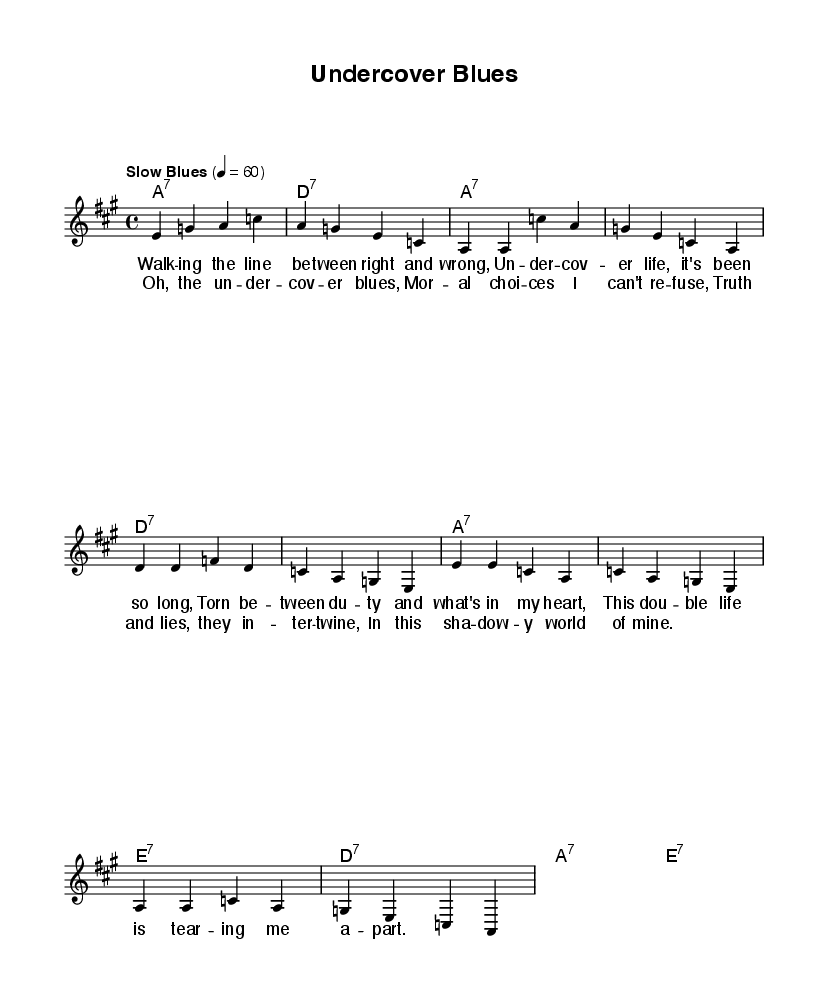What is the key signature of this music? The key signature is indicated by the presence of sharps or flats at the beginning of the staff. This piece is in A major, which has three sharps: F#, C#, and G#.
Answer: A major What is the time signature of this music? The time signature is shown at the beginning of the piece. It is written as 4/4, meaning there are four beats in each measure and the quarter note receives one beat.
Answer: 4/4 What is the tempo of this music? The tempo marking is placed above the staff and indicates the speed of the music. In this case, it states "Slow Blues" with a metronome marking of 60 beats per minute, indicating a slow tempo typical of blues music.
Answer: Slow Blues What is the main theme of the lyrics in the verses? By interpreting the lyrics provided, the themes revolve around moral dilemmas and the conflict between duty and personal feelings as an undercover agent. This reflects the struggles faced in a double life.
Answer: Moral dilemmas How many measures are in the chorus? The chorus consists of four lines with each line containing one measure. Therefore, there are a total of four measures in the chorus section.
Answer: Four measures What genre can this piece be classified as? The elements present in the music—like the structure of the chords, the style indicated by the tempo marking, and the lyrical content—point to it being a Blues song, which typically focuses on themes of hardship and emotional expression.
Answer: Blues What type of harmonic progression is used in this piece? The harmonic progression follows a common structure found in blues music, primarily consisting of dominant seventh chords which create a characteristic blues sound. The progression moves from A7 to D7 and E7, typical for blues.
Answer: Dominant seventh chords 